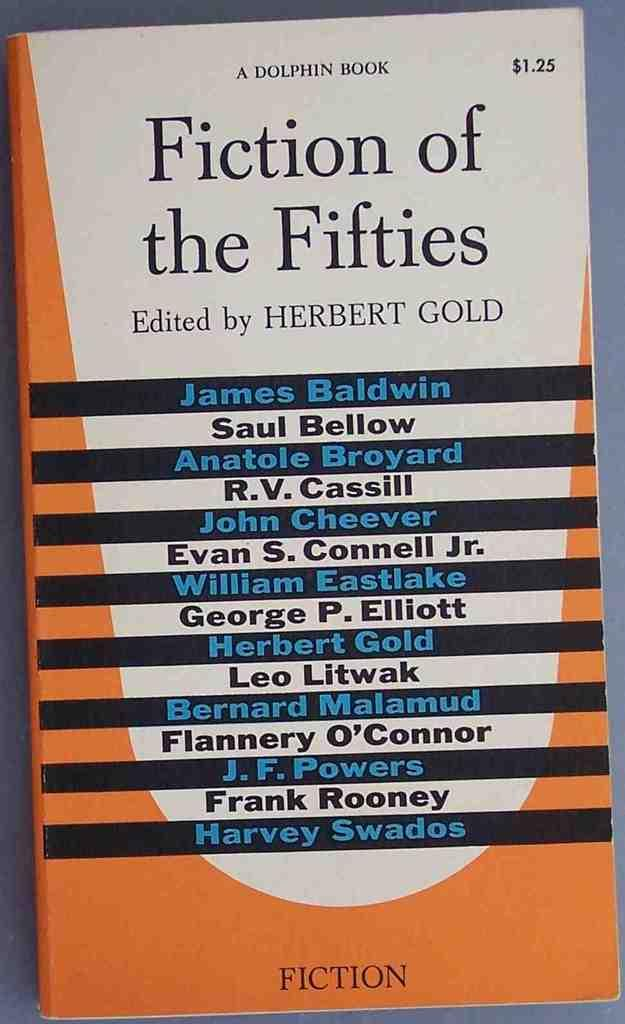<image>
Share a concise interpretation of the image provided. Book titled Fiction of the Fifties being sold for $1.25 